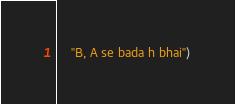<code> <loc_0><loc_0><loc_500><loc_500><_Python_>    "B, A se bada h bhai")
</code> 